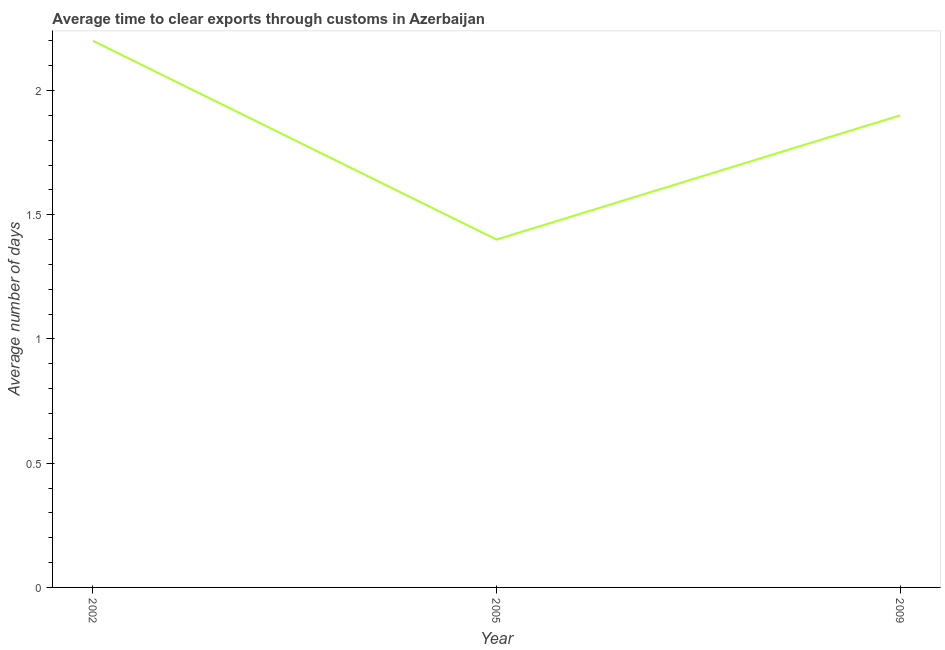Across all years, what is the maximum time to clear exports through customs?
Your answer should be compact. 2.2. Across all years, what is the minimum time to clear exports through customs?
Ensure brevity in your answer.  1.4. In which year was the time to clear exports through customs maximum?
Provide a short and direct response. 2002. In which year was the time to clear exports through customs minimum?
Provide a short and direct response. 2005. What is the sum of the time to clear exports through customs?
Your answer should be compact. 5.5. What is the difference between the time to clear exports through customs in 2002 and 2009?
Your response must be concise. 0.3. What is the average time to clear exports through customs per year?
Give a very brief answer. 1.83. What is the median time to clear exports through customs?
Your answer should be very brief. 1.9. In how many years, is the time to clear exports through customs greater than 0.30000000000000004 days?
Provide a short and direct response. 3. Do a majority of the years between 2009 and 2005 (inclusive) have time to clear exports through customs greater than 1 days?
Make the answer very short. No. What is the ratio of the time to clear exports through customs in 2002 to that in 2005?
Your answer should be compact. 1.57. Is the time to clear exports through customs in 2005 less than that in 2009?
Make the answer very short. Yes. What is the difference between the highest and the second highest time to clear exports through customs?
Your response must be concise. 0.3. Is the sum of the time to clear exports through customs in 2002 and 2009 greater than the maximum time to clear exports through customs across all years?
Offer a very short reply. Yes. What is the difference between the highest and the lowest time to clear exports through customs?
Ensure brevity in your answer.  0.8. In how many years, is the time to clear exports through customs greater than the average time to clear exports through customs taken over all years?
Give a very brief answer. 2. Does the time to clear exports through customs monotonically increase over the years?
Offer a terse response. No. What is the difference between two consecutive major ticks on the Y-axis?
Offer a very short reply. 0.5. What is the title of the graph?
Provide a succinct answer. Average time to clear exports through customs in Azerbaijan. What is the label or title of the X-axis?
Keep it short and to the point. Year. What is the label or title of the Y-axis?
Ensure brevity in your answer.  Average number of days. What is the Average number of days of 2002?
Offer a very short reply. 2.2. What is the Average number of days of 2005?
Make the answer very short. 1.4. What is the difference between the Average number of days in 2002 and 2005?
Provide a succinct answer. 0.8. What is the difference between the Average number of days in 2002 and 2009?
Make the answer very short. 0.3. What is the difference between the Average number of days in 2005 and 2009?
Offer a terse response. -0.5. What is the ratio of the Average number of days in 2002 to that in 2005?
Offer a very short reply. 1.57. What is the ratio of the Average number of days in 2002 to that in 2009?
Your response must be concise. 1.16. What is the ratio of the Average number of days in 2005 to that in 2009?
Ensure brevity in your answer.  0.74. 